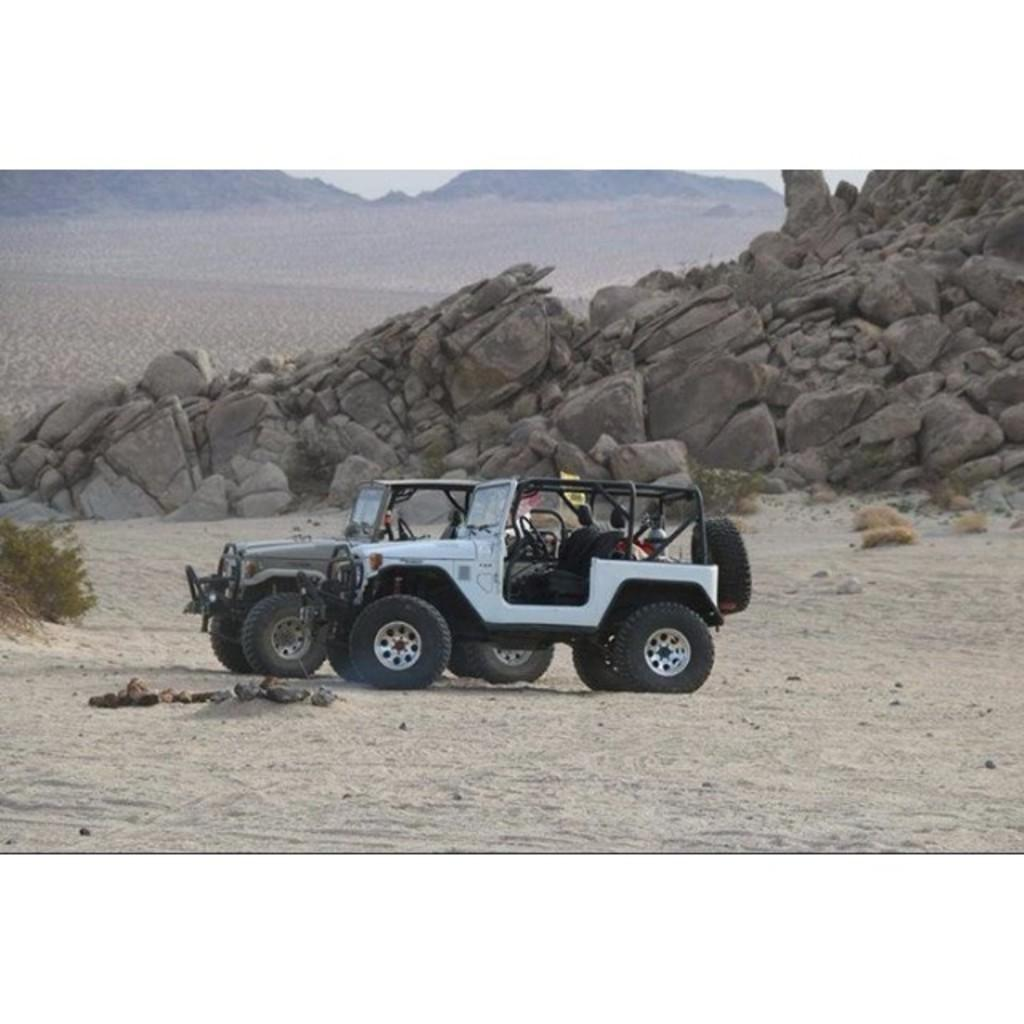How many jeeps are present in the image? There are two jeeps in the image. Where are the jeeps located? The jeeps are on the ground. What can be seen in the background of the image? There are mountains and the sky visible in the background of the image. What time of day might the image have been taken? The image was likely taken during the day, as the sky is visible. What type of pin is holding the attention of the jeeps in the image? There is no pin present in the image, and the jeeps are not shown to be paying attention to anything. 